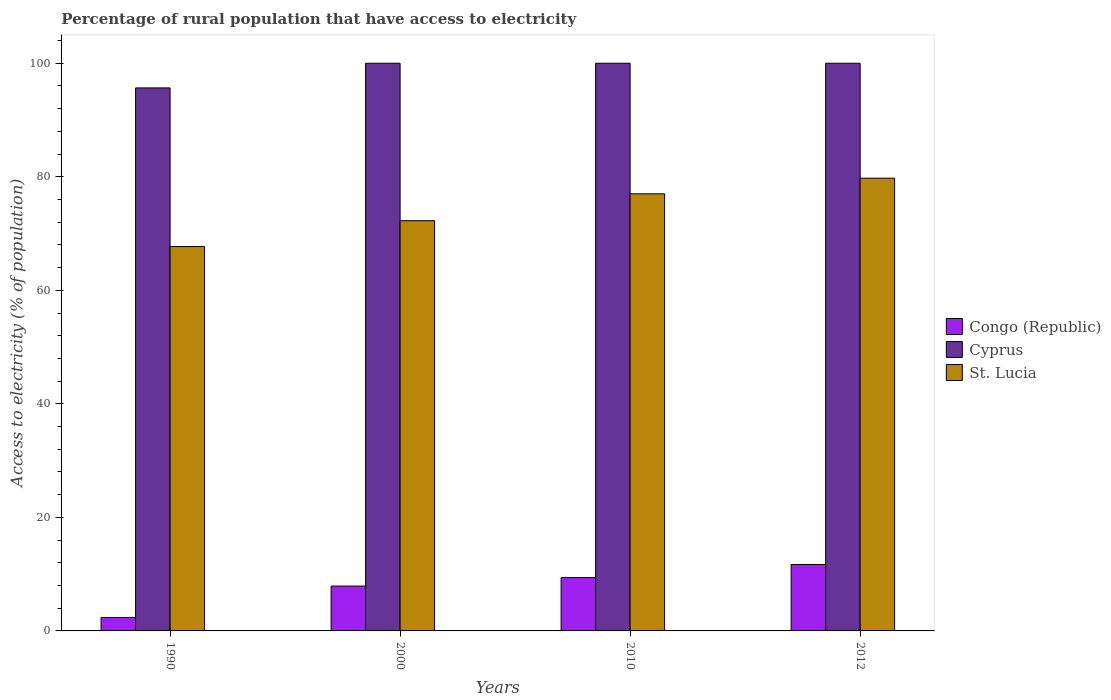How many different coloured bars are there?
Provide a succinct answer. 3. Are the number of bars per tick equal to the number of legend labels?
Offer a very short reply. Yes. Are the number of bars on each tick of the X-axis equal?
Offer a terse response. Yes. How many bars are there on the 3rd tick from the left?
Keep it short and to the point. 3. What is the label of the 1st group of bars from the left?
Your answer should be compact. 1990. Across all years, what is the minimum percentage of rural population that have access to electricity in St. Lucia?
Provide a succinct answer. 67.71. What is the total percentage of rural population that have access to electricity in Congo (Republic) in the graph?
Offer a terse response. 31.37. What is the difference between the percentage of rural population that have access to electricity in Congo (Republic) in 1990 and that in 2000?
Offer a very short reply. -5.53. What is the difference between the percentage of rural population that have access to electricity in Cyprus in 2012 and the percentage of rural population that have access to electricity in St. Lucia in 1990?
Ensure brevity in your answer.  32.29. What is the average percentage of rural population that have access to electricity in Congo (Republic) per year?
Give a very brief answer. 7.84. In the year 2000, what is the difference between the percentage of rural population that have access to electricity in Congo (Republic) and percentage of rural population that have access to electricity in Cyprus?
Give a very brief answer. -92.1. What is the ratio of the percentage of rural population that have access to electricity in St. Lucia in 1990 to that in 2000?
Provide a short and direct response. 0.94. Is the percentage of rural population that have access to electricity in St. Lucia in 1990 less than that in 2010?
Make the answer very short. Yes. What is the difference between the highest and the second highest percentage of rural population that have access to electricity in St. Lucia?
Ensure brevity in your answer.  2.75. What is the difference between the highest and the lowest percentage of rural population that have access to electricity in St. Lucia?
Make the answer very short. 12.04. In how many years, is the percentage of rural population that have access to electricity in Congo (Republic) greater than the average percentage of rural population that have access to electricity in Congo (Republic) taken over all years?
Your response must be concise. 3. What does the 1st bar from the left in 1990 represents?
Ensure brevity in your answer.  Congo (Republic). What does the 3rd bar from the right in 2012 represents?
Your response must be concise. Congo (Republic). How many bars are there?
Ensure brevity in your answer.  12. What is the difference between two consecutive major ticks on the Y-axis?
Offer a terse response. 20. Does the graph contain grids?
Ensure brevity in your answer.  No. Where does the legend appear in the graph?
Provide a succinct answer. Center right. How are the legend labels stacked?
Provide a short and direct response. Vertical. What is the title of the graph?
Your response must be concise. Percentage of rural population that have access to electricity. Does "Cambodia" appear as one of the legend labels in the graph?
Ensure brevity in your answer.  No. What is the label or title of the Y-axis?
Make the answer very short. Access to electricity (% of population). What is the Access to electricity (% of population) of Congo (Republic) in 1990?
Your answer should be compact. 2.37. What is the Access to electricity (% of population) in Cyprus in 1990?
Provide a succinct answer. 95.66. What is the Access to electricity (% of population) of St. Lucia in 1990?
Provide a short and direct response. 67.71. What is the Access to electricity (% of population) in Congo (Republic) in 2000?
Offer a very short reply. 7.9. What is the Access to electricity (% of population) of St. Lucia in 2000?
Keep it short and to the point. 72.27. What is the Access to electricity (% of population) in Congo (Republic) in 2010?
Provide a short and direct response. 9.4. What is the Access to electricity (% of population) of St. Lucia in 2010?
Offer a terse response. 77. What is the Access to electricity (% of population) in Congo (Republic) in 2012?
Provide a succinct answer. 11.7. What is the Access to electricity (% of population) of St. Lucia in 2012?
Your answer should be very brief. 79.75. Across all years, what is the maximum Access to electricity (% of population) in St. Lucia?
Your answer should be compact. 79.75. Across all years, what is the minimum Access to electricity (% of population) of Congo (Republic)?
Offer a very short reply. 2.37. Across all years, what is the minimum Access to electricity (% of population) of Cyprus?
Ensure brevity in your answer.  95.66. Across all years, what is the minimum Access to electricity (% of population) of St. Lucia?
Ensure brevity in your answer.  67.71. What is the total Access to electricity (% of population) of Congo (Republic) in the graph?
Your response must be concise. 31.37. What is the total Access to electricity (% of population) of Cyprus in the graph?
Your answer should be compact. 395.66. What is the total Access to electricity (% of population) in St. Lucia in the graph?
Keep it short and to the point. 296.73. What is the difference between the Access to electricity (% of population) in Congo (Republic) in 1990 and that in 2000?
Your response must be concise. -5.53. What is the difference between the Access to electricity (% of population) in Cyprus in 1990 and that in 2000?
Your answer should be compact. -4.34. What is the difference between the Access to electricity (% of population) in St. Lucia in 1990 and that in 2000?
Your answer should be very brief. -4.55. What is the difference between the Access to electricity (% of population) of Congo (Republic) in 1990 and that in 2010?
Make the answer very short. -7.03. What is the difference between the Access to electricity (% of population) in Cyprus in 1990 and that in 2010?
Keep it short and to the point. -4.34. What is the difference between the Access to electricity (% of population) of St. Lucia in 1990 and that in 2010?
Your answer should be very brief. -9.29. What is the difference between the Access to electricity (% of population) in Congo (Republic) in 1990 and that in 2012?
Offer a terse response. -9.33. What is the difference between the Access to electricity (% of population) in Cyprus in 1990 and that in 2012?
Provide a succinct answer. -4.34. What is the difference between the Access to electricity (% of population) of St. Lucia in 1990 and that in 2012?
Give a very brief answer. -12.04. What is the difference between the Access to electricity (% of population) in Cyprus in 2000 and that in 2010?
Give a very brief answer. 0. What is the difference between the Access to electricity (% of population) of St. Lucia in 2000 and that in 2010?
Make the answer very short. -4.74. What is the difference between the Access to electricity (% of population) of St. Lucia in 2000 and that in 2012?
Give a very brief answer. -7.49. What is the difference between the Access to electricity (% of population) of St. Lucia in 2010 and that in 2012?
Your answer should be very brief. -2.75. What is the difference between the Access to electricity (% of population) in Congo (Republic) in 1990 and the Access to electricity (% of population) in Cyprus in 2000?
Provide a succinct answer. -97.63. What is the difference between the Access to electricity (% of population) in Congo (Republic) in 1990 and the Access to electricity (% of population) in St. Lucia in 2000?
Your answer should be compact. -69.9. What is the difference between the Access to electricity (% of population) of Cyprus in 1990 and the Access to electricity (% of population) of St. Lucia in 2000?
Your answer should be compact. 23.39. What is the difference between the Access to electricity (% of population) of Congo (Republic) in 1990 and the Access to electricity (% of population) of Cyprus in 2010?
Ensure brevity in your answer.  -97.63. What is the difference between the Access to electricity (% of population) in Congo (Republic) in 1990 and the Access to electricity (% of population) in St. Lucia in 2010?
Ensure brevity in your answer.  -74.63. What is the difference between the Access to electricity (% of population) in Cyprus in 1990 and the Access to electricity (% of population) in St. Lucia in 2010?
Offer a very short reply. 18.66. What is the difference between the Access to electricity (% of population) of Congo (Republic) in 1990 and the Access to electricity (% of population) of Cyprus in 2012?
Your answer should be compact. -97.63. What is the difference between the Access to electricity (% of population) of Congo (Republic) in 1990 and the Access to electricity (% of population) of St. Lucia in 2012?
Provide a short and direct response. -77.38. What is the difference between the Access to electricity (% of population) of Cyprus in 1990 and the Access to electricity (% of population) of St. Lucia in 2012?
Offer a very short reply. 15.91. What is the difference between the Access to electricity (% of population) in Congo (Republic) in 2000 and the Access to electricity (% of population) in Cyprus in 2010?
Ensure brevity in your answer.  -92.1. What is the difference between the Access to electricity (% of population) in Congo (Republic) in 2000 and the Access to electricity (% of population) in St. Lucia in 2010?
Your response must be concise. -69.1. What is the difference between the Access to electricity (% of population) in Congo (Republic) in 2000 and the Access to electricity (% of population) in Cyprus in 2012?
Ensure brevity in your answer.  -92.1. What is the difference between the Access to electricity (% of population) in Congo (Republic) in 2000 and the Access to electricity (% of population) in St. Lucia in 2012?
Ensure brevity in your answer.  -71.85. What is the difference between the Access to electricity (% of population) in Cyprus in 2000 and the Access to electricity (% of population) in St. Lucia in 2012?
Your response must be concise. 20.25. What is the difference between the Access to electricity (% of population) of Congo (Republic) in 2010 and the Access to electricity (% of population) of Cyprus in 2012?
Keep it short and to the point. -90.6. What is the difference between the Access to electricity (% of population) in Congo (Republic) in 2010 and the Access to electricity (% of population) in St. Lucia in 2012?
Your response must be concise. -70.35. What is the difference between the Access to electricity (% of population) of Cyprus in 2010 and the Access to electricity (% of population) of St. Lucia in 2012?
Give a very brief answer. 20.25. What is the average Access to electricity (% of population) of Congo (Republic) per year?
Provide a short and direct response. 7.84. What is the average Access to electricity (% of population) in Cyprus per year?
Provide a succinct answer. 98.92. What is the average Access to electricity (% of population) in St. Lucia per year?
Your response must be concise. 74.18. In the year 1990, what is the difference between the Access to electricity (% of population) of Congo (Republic) and Access to electricity (% of population) of Cyprus?
Provide a succinct answer. -93.29. In the year 1990, what is the difference between the Access to electricity (% of population) in Congo (Republic) and Access to electricity (% of population) in St. Lucia?
Provide a succinct answer. -65.34. In the year 1990, what is the difference between the Access to electricity (% of population) of Cyprus and Access to electricity (% of population) of St. Lucia?
Provide a short and direct response. 27.95. In the year 2000, what is the difference between the Access to electricity (% of population) in Congo (Republic) and Access to electricity (% of population) in Cyprus?
Give a very brief answer. -92.1. In the year 2000, what is the difference between the Access to electricity (% of population) in Congo (Republic) and Access to electricity (% of population) in St. Lucia?
Provide a succinct answer. -64.36. In the year 2000, what is the difference between the Access to electricity (% of population) in Cyprus and Access to electricity (% of population) in St. Lucia?
Offer a terse response. 27.73. In the year 2010, what is the difference between the Access to electricity (% of population) in Congo (Republic) and Access to electricity (% of population) in Cyprus?
Provide a short and direct response. -90.6. In the year 2010, what is the difference between the Access to electricity (% of population) in Congo (Republic) and Access to electricity (% of population) in St. Lucia?
Keep it short and to the point. -67.6. In the year 2010, what is the difference between the Access to electricity (% of population) of Cyprus and Access to electricity (% of population) of St. Lucia?
Make the answer very short. 23. In the year 2012, what is the difference between the Access to electricity (% of population) in Congo (Republic) and Access to electricity (% of population) in Cyprus?
Your response must be concise. -88.3. In the year 2012, what is the difference between the Access to electricity (% of population) of Congo (Republic) and Access to electricity (% of population) of St. Lucia?
Give a very brief answer. -68.05. In the year 2012, what is the difference between the Access to electricity (% of population) in Cyprus and Access to electricity (% of population) in St. Lucia?
Provide a short and direct response. 20.25. What is the ratio of the Access to electricity (% of population) of Cyprus in 1990 to that in 2000?
Provide a succinct answer. 0.96. What is the ratio of the Access to electricity (% of population) of St. Lucia in 1990 to that in 2000?
Give a very brief answer. 0.94. What is the ratio of the Access to electricity (% of population) of Congo (Republic) in 1990 to that in 2010?
Provide a short and direct response. 0.25. What is the ratio of the Access to electricity (% of population) of Cyprus in 1990 to that in 2010?
Provide a succinct answer. 0.96. What is the ratio of the Access to electricity (% of population) in St. Lucia in 1990 to that in 2010?
Your answer should be very brief. 0.88. What is the ratio of the Access to electricity (% of population) in Congo (Republic) in 1990 to that in 2012?
Keep it short and to the point. 0.2. What is the ratio of the Access to electricity (% of population) in Cyprus in 1990 to that in 2012?
Provide a short and direct response. 0.96. What is the ratio of the Access to electricity (% of population) in St. Lucia in 1990 to that in 2012?
Offer a very short reply. 0.85. What is the ratio of the Access to electricity (% of population) of Congo (Republic) in 2000 to that in 2010?
Keep it short and to the point. 0.84. What is the ratio of the Access to electricity (% of population) of Cyprus in 2000 to that in 2010?
Your answer should be compact. 1. What is the ratio of the Access to electricity (% of population) of St. Lucia in 2000 to that in 2010?
Your answer should be compact. 0.94. What is the ratio of the Access to electricity (% of population) in Congo (Republic) in 2000 to that in 2012?
Provide a short and direct response. 0.68. What is the ratio of the Access to electricity (% of population) in St. Lucia in 2000 to that in 2012?
Ensure brevity in your answer.  0.91. What is the ratio of the Access to electricity (% of population) of Congo (Republic) in 2010 to that in 2012?
Keep it short and to the point. 0.8. What is the ratio of the Access to electricity (% of population) of Cyprus in 2010 to that in 2012?
Give a very brief answer. 1. What is the ratio of the Access to electricity (% of population) in St. Lucia in 2010 to that in 2012?
Your answer should be very brief. 0.97. What is the difference between the highest and the second highest Access to electricity (% of population) in St. Lucia?
Your response must be concise. 2.75. What is the difference between the highest and the lowest Access to electricity (% of population) in Congo (Republic)?
Your answer should be very brief. 9.33. What is the difference between the highest and the lowest Access to electricity (% of population) of Cyprus?
Keep it short and to the point. 4.34. What is the difference between the highest and the lowest Access to electricity (% of population) in St. Lucia?
Offer a very short reply. 12.04. 